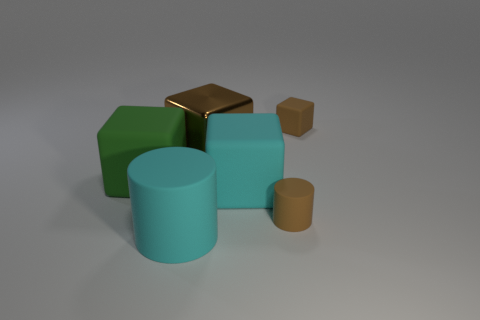Subtract all brown matte cubes. How many cubes are left? 3 Subtract all purple spheres. How many brown cubes are left? 2 Subtract all cyan cubes. How many cubes are left? 3 Subtract 2 cubes. How many cubes are left? 2 Subtract all blue blocks. Subtract all gray spheres. How many blocks are left? 4 Add 1 large green balls. How many objects exist? 7 Subtract all blocks. How many objects are left? 2 Subtract 0 purple cylinders. How many objects are left? 6 Subtract all tiny rubber things. Subtract all large metallic cubes. How many objects are left? 3 Add 6 big brown metallic things. How many big brown metallic things are left? 7 